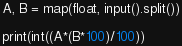Convert code to text. <code><loc_0><loc_0><loc_500><loc_500><_Python_>A, B = map(float, input().split())

print(int((A*(B*100)/100))</code> 